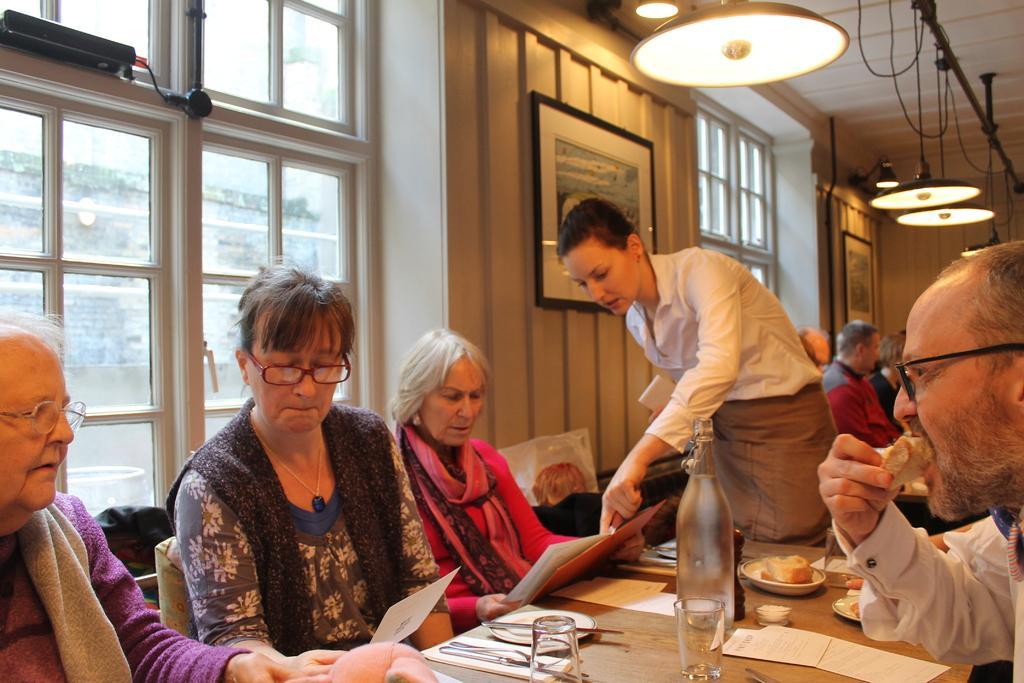In one or two sentences, can you explain what this image depicts? Here we can see a group of people sitting in chairs with table in front of them having glasses and bottle on it and there is a woman standing here taking in order woman old man and at the top we can see lights 